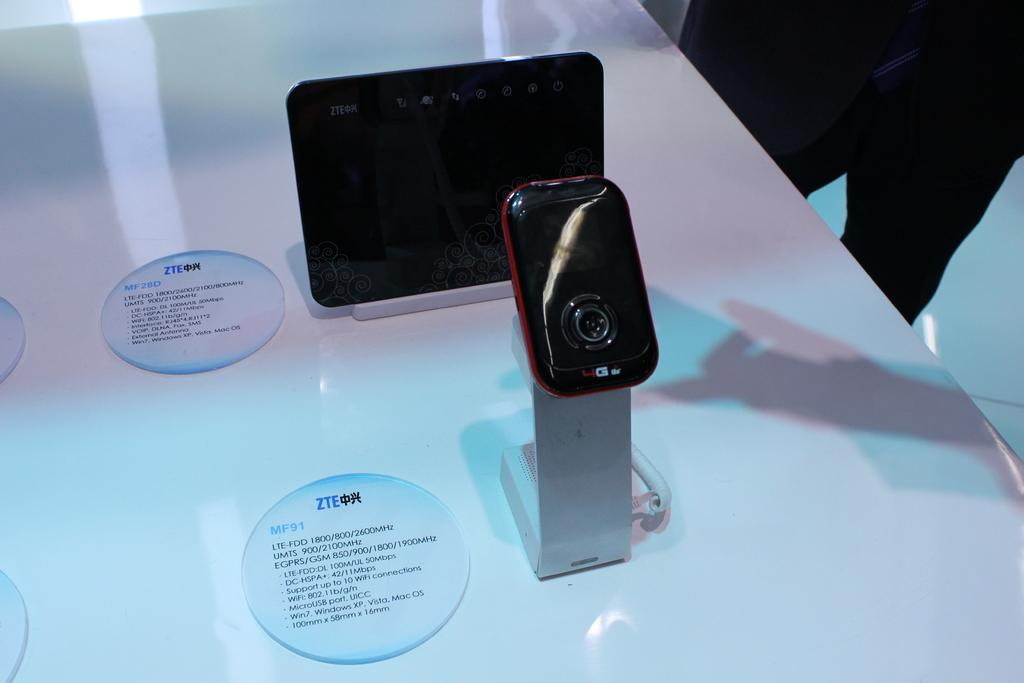<image>
Render a clear and concise summary of the photo. a small black phone on display labeled 4G 